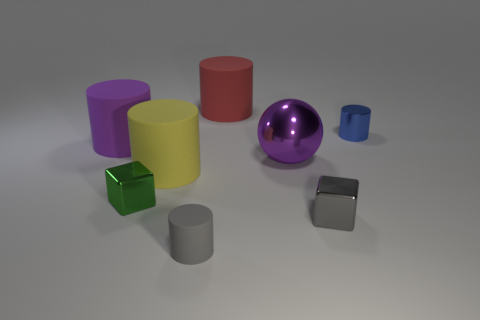What is the material of the thing that is the same color as the large ball?
Your answer should be very brief. Rubber. Are there more small green metallic objects that are behind the yellow matte object than rubber cylinders behind the gray metallic object?
Ensure brevity in your answer.  No. How big is the yellow cylinder?
Provide a succinct answer. Large. Is there another object of the same shape as the small blue shiny object?
Your answer should be very brief. Yes. Is the shape of the small matte object the same as the thing that is behind the tiny shiny cylinder?
Offer a terse response. Yes. There is a cylinder that is in front of the purple metal sphere and right of the big yellow cylinder; what size is it?
Make the answer very short. Small. How many small cubes are there?
Your answer should be very brief. 2. There is a sphere that is the same size as the purple matte cylinder; what is its material?
Keep it short and to the point. Metal. Is there a purple shiny object of the same size as the yellow rubber object?
Give a very brief answer. Yes. There is a metallic block that is on the right side of the tiny gray cylinder; does it have the same color as the rubber cylinder that is in front of the yellow thing?
Provide a succinct answer. Yes. 